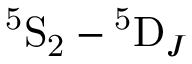Convert formula to latex. <formula><loc_0><loc_0><loc_500><loc_500>^ { 5 } S _ { 2 } - ^ { 5 } D _ { J }</formula> 